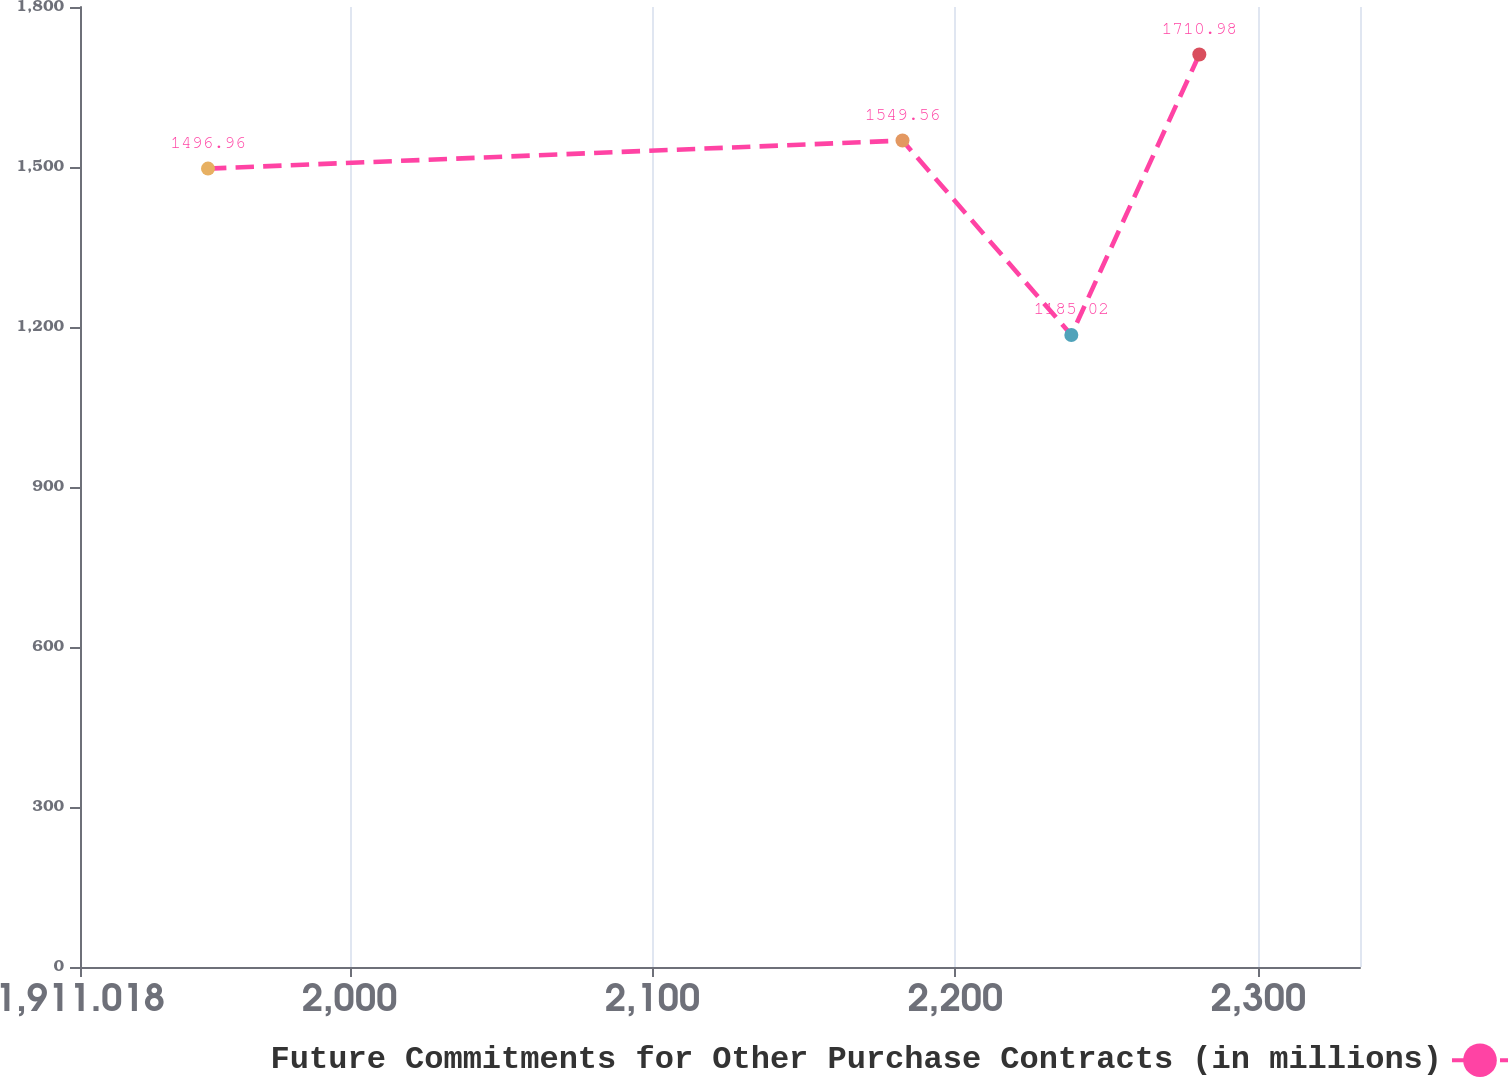Convert chart to OTSL. <chart><loc_0><loc_0><loc_500><loc_500><line_chart><ecel><fcel>Future Commitments for Other Purchase Contracts (in millions)<nl><fcel>1953.27<fcel>1496.96<nl><fcel>2182.52<fcel>1549.56<nl><fcel>2238.25<fcel>1185.02<nl><fcel>2280.5<fcel>1710.98<nl><fcel>2375.79<fcel>1351.34<nl></chart> 